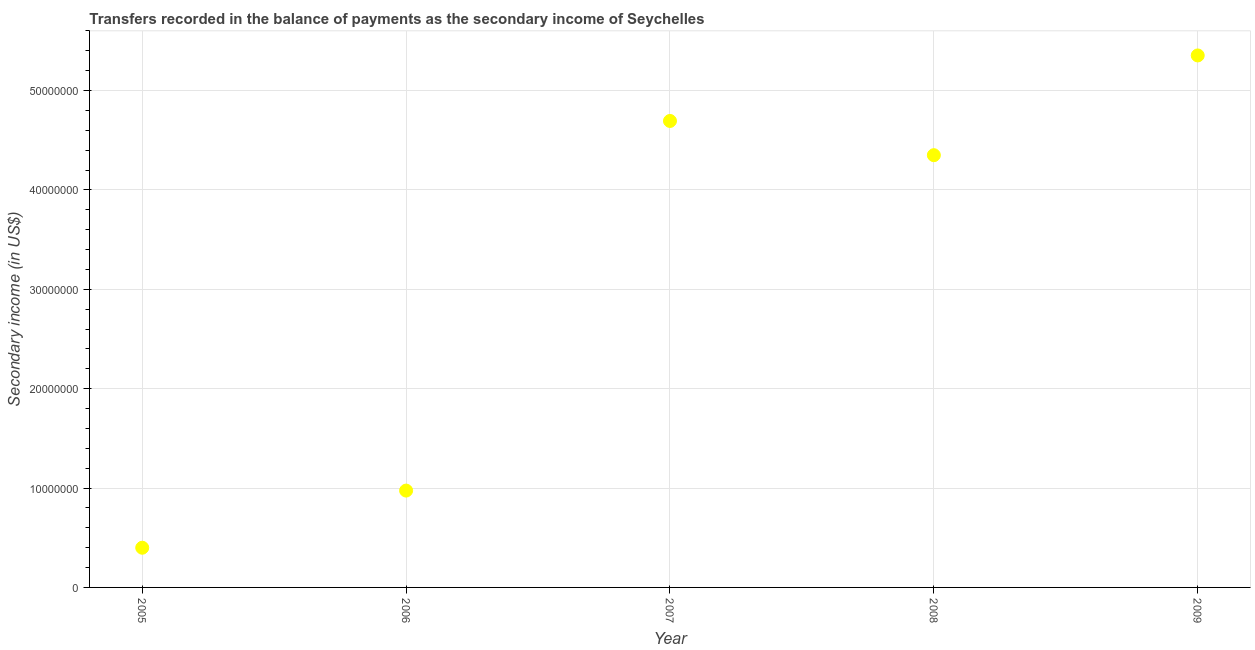What is the amount of secondary income in 2007?
Keep it short and to the point. 4.69e+07. Across all years, what is the maximum amount of secondary income?
Your answer should be very brief. 5.35e+07. Across all years, what is the minimum amount of secondary income?
Offer a terse response. 3.99e+06. In which year was the amount of secondary income maximum?
Ensure brevity in your answer.  2009. In which year was the amount of secondary income minimum?
Your answer should be very brief. 2005. What is the sum of the amount of secondary income?
Ensure brevity in your answer.  1.58e+08. What is the difference between the amount of secondary income in 2006 and 2007?
Give a very brief answer. -3.72e+07. What is the average amount of secondary income per year?
Offer a very short reply. 3.15e+07. What is the median amount of secondary income?
Your answer should be very brief. 4.35e+07. In how many years, is the amount of secondary income greater than 38000000 US$?
Ensure brevity in your answer.  3. Do a majority of the years between 2005 and 2007 (inclusive) have amount of secondary income greater than 22000000 US$?
Your response must be concise. No. What is the ratio of the amount of secondary income in 2008 to that in 2009?
Provide a succinct answer. 0.81. What is the difference between the highest and the second highest amount of secondary income?
Make the answer very short. 6.59e+06. Is the sum of the amount of secondary income in 2008 and 2009 greater than the maximum amount of secondary income across all years?
Keep it short and to the point. Yes. What is the difference between the highest and the lowest amount of secondary income?
Keep it short and to the point. 4.95e+07. In how many years, is the amount of secondary income greater than the average amount of secondary income taken over all years?
Make the answer very short. 3. Does the amount of secondary income monotonically increase over the years?
Offer a very short reply. No. How many dotlines are there?
Offer a terse response. 1. What is the difference between two consecutive major ticks on the Y-axis?
Keep it short and to the point. 1.00e+07. Are the values on the major ticks of Y-axis written in scientific E-notation?
Provide a succinct answer. No. Does the graph contain any zero values?
Provide a succinct answer. No. Does the graph contain grids?
Provide a short and direct response. Yes. What is the title of the graph?
Your answer should be very brief. Transfers recorded in the balance of payments as the secondary income of Seychelles. What is the label or title of the X-axis?
Ensure brevity in your answer.  Year. What is the label or title of the Y-axis?
Keep it short and to the point. Secondary income (in US$). What is the Secondary income (in US$) in 2005?
Your answer should be very brief. 3.99e+06. What is the Secondary income (in US$) in 2006?
Ensure brevity in your answer.  9.75e+06. What is the Secondary income (in US$) in 2007?
Provide a short and direct response. 4.69e+07. What is the Secondary income (in US$) in 2008?
Provide a short and direct response. 4.35e+07. What is the Secondary income (in US$) in 2009?
Your answer should be compact. 5.35e+07. What is the difference between the Secondary income (in US$) in 2005 and 2006?
Provide a short and direct response. -5.75e+06. What is the difference between the Secondary income (in US$) in 2005 and 2007?
Ensure brevity in your answer.  -4.29e+07. What is the difference between the Secondary income (in US$) in 2005 and 2008?
Offer a terse response. -3.95e+07. What is the difference between the Secondary income (in US$) in 2005 and 2009?
Give a very brief answer. -4.95e+07. What is the difference between the Secondary income (in US$) in 2006 and 2007?
Provide a short and direct response. -3.72e+07. What is the difference between the Secondary income (in US$) in 2006 and 2008?
Make the answer very short. -3.38e+07. What is the difference between the Secondary income (in US$) in 2006 and 2009?
Make the answer very short. -4.38e+07. What is the difference between the Secondary income (in US$) in 2007 and 2008?
Give a very brief answer. 3.44e+06. What is the difference between the Secondary income (in US$) in 2007 and 2009?
Offer a terse response. -6.59e+06. What is the difference between the Secondary income (in US$) in 2008 and 2009?
Provide a succinct answer. -1.00e+07. What is the ratio of the Secondary income (in US$) in 2005 to that in 2006?
Offer a very short reply. 0.41. What is the ratio of the Secondary income (in US$) in 2005 to that in 2007?
Make the answer very short. 0.09. What is the ratio of the Secondary income (in US$) in 2005 to that in 2008?
Keep it short and to the point. 0.09. What is the ratio of the Secondary income (in US$) in 2005 to that in 2009?
Give a very brief answer. 0.07. What is the ratio of the Secondary income (in US$) in 2006 to that in 2007?
Provide a succinct answer. 0.21. What is the ratio of the Secondary income (in US$) in 2006 to that in 2008?
Keep it short and to the point. 0.22. What is the ratio of the Secondary income (in US$) in 2006 to that in 2009?
Provide a succinct answer. 0.18. What is the ratio of the Secondary income (in US$) in 2007 to that in 2008?
Provide a succinct answer. 1.08. What is the ratio of the Secondary income (in US$) in 2007 to that in 2009?
Offer a very short reply. 0.88. What is the ratio of the Secondary income (in US$) in 2008 to that in 2009?
Your response must be concise. 0.81. 